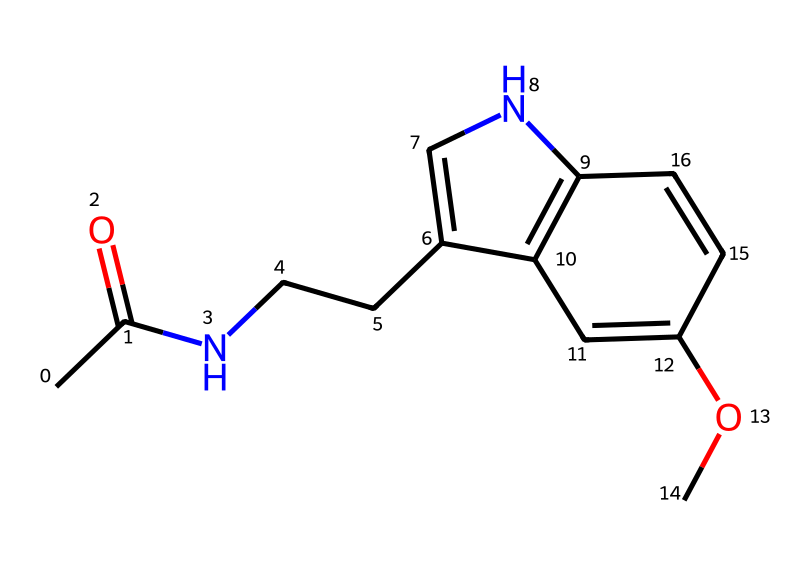What is the molecular formula of melatonin? By analyzing the provided SMILES representation, we can deduce the presence of atoms: carbon (C), hydrogen (H), nitrogen (N), and oxygen (O). Counting the atoms leads us to the molecular formula C13H16N2O2.
Answer: C13H16N2O2 How many nitrogen atoms are present in this chemical structure? Looking at the SMILES, we can locate the nitrogen (N) atoms. There are exactly two nitrogen atoms in the structure, indicated by the 'N' characters.
Answer: 2 What type of chemical bonds are primarily present in melatonin? In the chemical structure represented by the SMILES, we see both single bonds and double bonds. The double bond can be identified next to the carbonyl (C=O) group, while the rest are mostly single bonds.
Answer: single and double bonds Which functional group is present in melatonin that contributes to its biological activity? Examining the structure shows the presence of an amide group (R-CO-NR2), which is a result of the carbonyl bonded to the nitrogen. This functional group plays a significant role in biological activity and interactions.
Answer: amide group What characteristic does melatonin exhibit due to its aromatic rings? The structure features aromatic systems in the indole part of the compound. The pi-electron cloud in these rings allows for resonance stabilization, contributing to its pharmacological properties.
Answer: resonance stabilization What is the role of the methoxy group in the chemical structure of melatonin? In the SMILES, the methoxy group (-OCH3) enhances the solubility and can influence the pharmacokinetics of melatonin, thus affecting its activity in the body, particularly in sleep regulation.
Answer: enhances solubility 